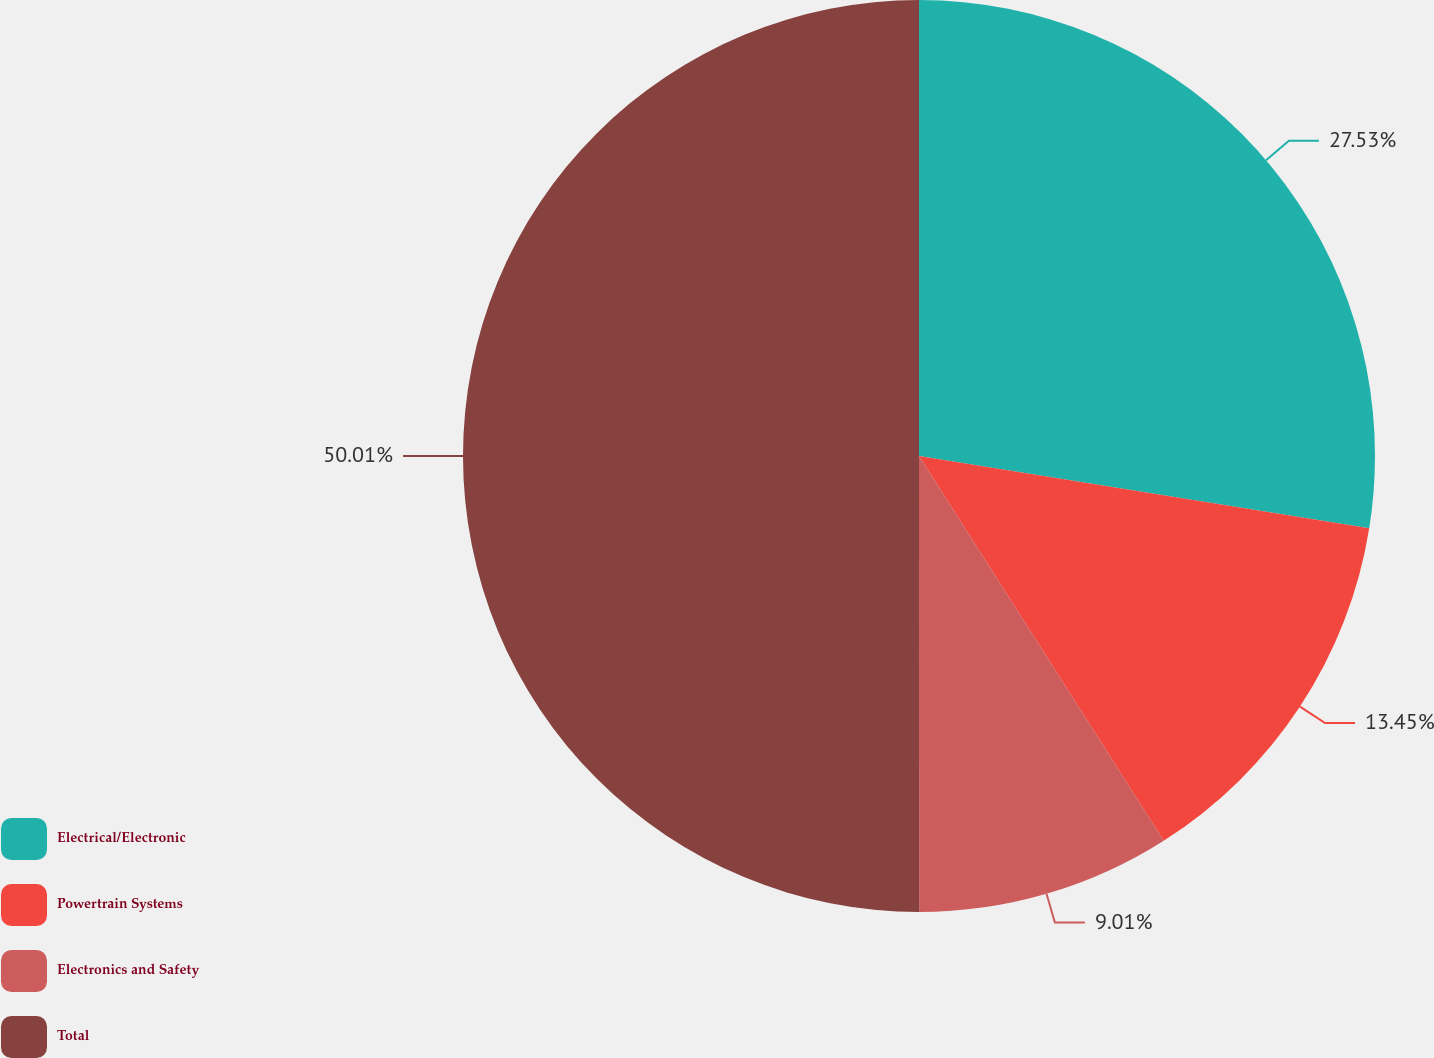Convert chart to OTSL. <chart><loc_0><loc_0><loc_500><loc_500><pie_chart><fcel>Electrical/Electronic<fcel>Powertrain Systems<fcel>Electronics and Safety<fcel>Total<nl><fcel>27.53%<fcel>13.45%<fcel>9.01%<fcel>50.0%<nl></chart> 